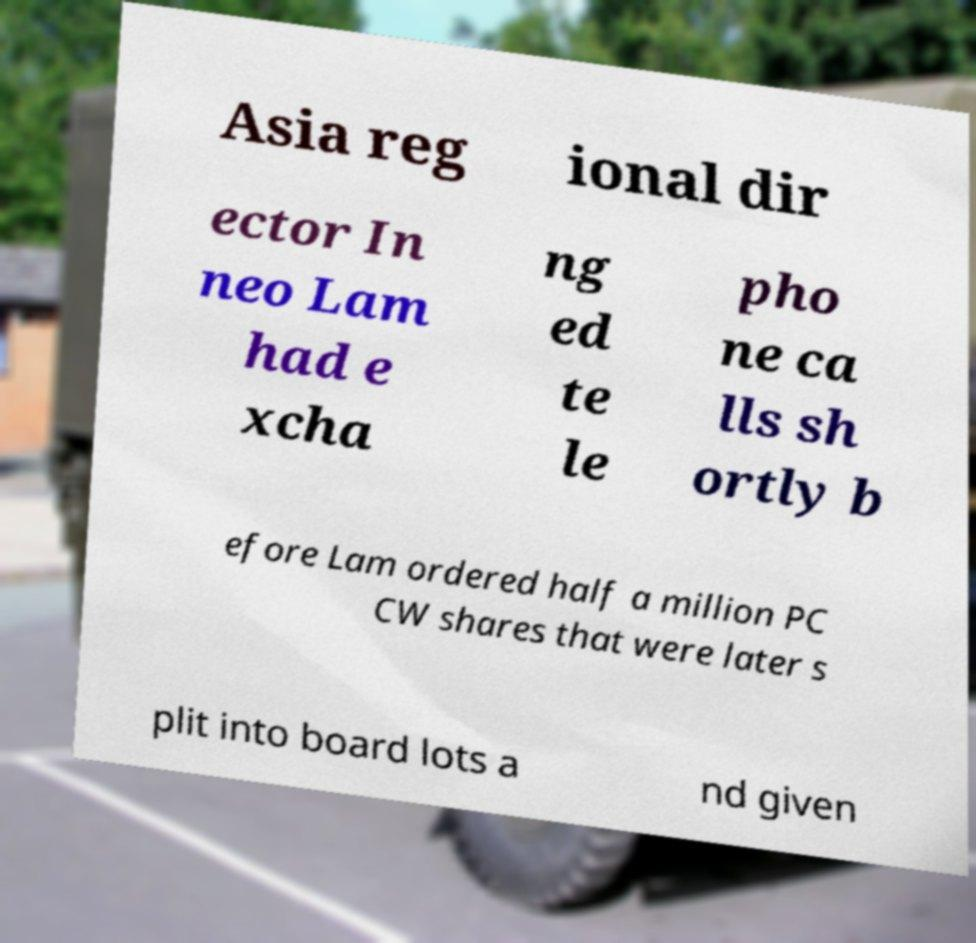For documentation purposes, I need the text within this image transcribed. Could you provide that? Asia reg ional dir ector In neo Lam had e xcha ng ed te le pho ne ca lls sh ortly b efore Lam ordered half a million PC CW shares that were later s plit into board lots a nd given 